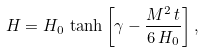Convert formula to latex. <formula><loc_0><loc_0><loc_500><loc_500>H = H _ { 0 } \, \tanh { \left [ \gamma - \frac { M ^ { 2 } \, t } { 6 \, H _ { 0 } } \right ] } \, ,</formula> 